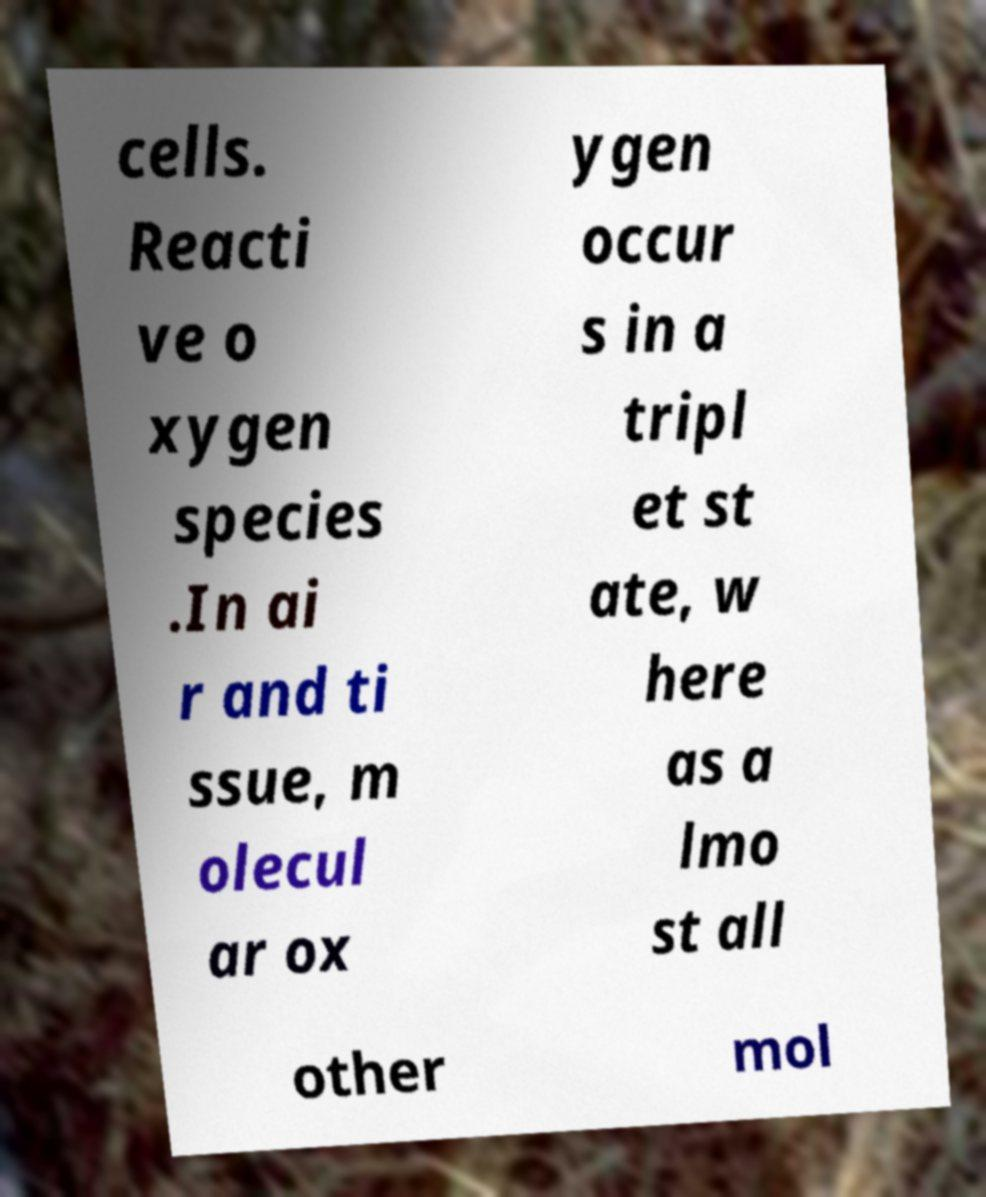Please read and relay the text visible in this image. What does it say? cells. Reacti ve o xygen species .In ai r and ti ssue, m olecul ar ox ygen occur s in a tripl et st ate, w here as a lmo st all other mol 